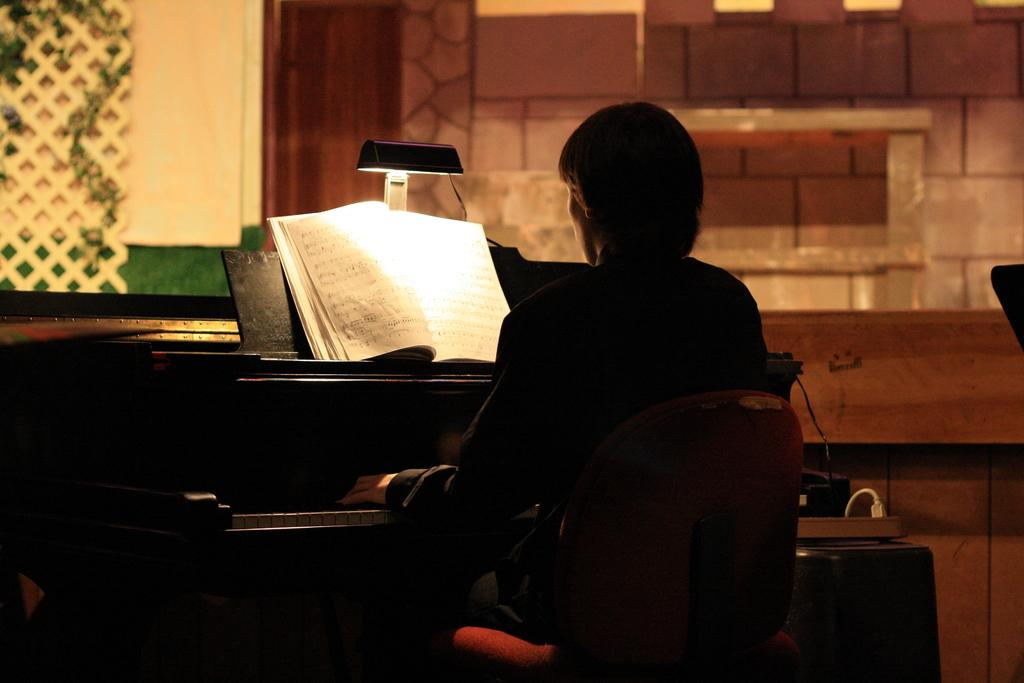What is the man in the image doing? The man is sitting and playing the piano. What might be helping the man play the piano? There is a book with musical instructions in front of the man. What object is providing light in the image? There is a lamp in the image. Can you tell me how long the snake is in the image? There is no snake present in the image. What measurement can be taken from the man's nose in the image? There is no need to measure the man's nose in the image, as it is not relevant to the provided facts. 